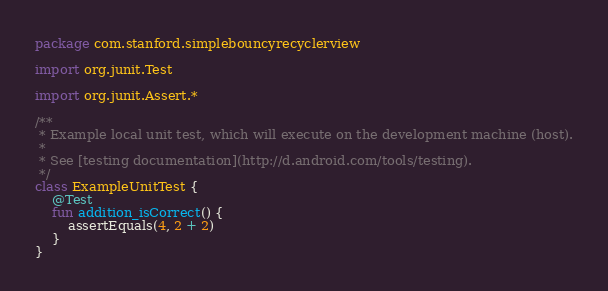Convert code to text. <code><loc_0><loc_0><loc_500><loc_500><_Kotlin_>package com.stanford.simplebouncyrecyclerview

import org.junit.Test

import org.junit.Assert.*

/**
 * Example local unit test, which will execute on the development machine (host).
 *
 * See [testing documentation](http://d.android.com/tools/testing).
 */
class ExampleUnitTest {
    @Test
    fun addition_isCorrect() {
        assertEquals(4, 2 + 2)
    }
}
</code> 